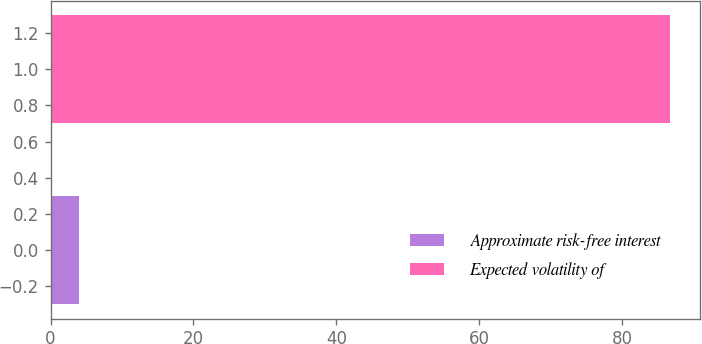<chart> <loc_0><loc_0><loc_500><loc_500><bar_chart><fcel>Approximate risk-free interest<fcel>Expected volatility of<nl><fcel>4<fcel>86.6<nl></chart> 